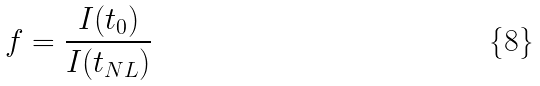Convert formula to latex. <formula><loc_0><loc_0><loc_500><loc_500>f = \frac { I ( t _ { 0 } ) } { I ( t _ { N L } ) }</formula> 